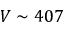<formula> <loc_0><loc_0><loc_500><loc_500>V \sim 4 0 7</formula> 